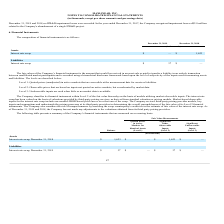According to Maxlinear's financial document, How is the fair value of the company's financial instrument defined? The fair values of the Company’s financial instrument is the amount that would be received in an asset sale or paid to transfer a liability in an orderly transaction between unaffiliated market participants and is recorded using a hierarchical disclosure framework based upon the level of subjectivity of the inputs used in measuring assets and liabilities.. The document states: "The fair values of the Company’s financial instrument is the amount that would be received in an asset sale or paid to transfer a liability in an orde..." Also, What was the interest rate swap in 2019 and 2018 respectively? The document shows two values: 0 and 1,623 (in thousands). From the document: "December 31, 2019 December 31, 2018 Interest rate swap $ — $ 1,623..." Additionally, In which year was interest rate swap less than 1,000 thousands? According to the financial document, 2019. The relevant text states: "December 31, 2019 December 31, 2018..." Also, can you calculate: What was the change in the interest rate swap from 2018 to 2019? Based on the calculation: 0 - 1,623, the result is -1623 (in thousands). This is based on the information: "December 31, 2019 December 31, 2018 Interest rate swap $ — $ 1,623..." The key data points involved are: 0, 1,623. Also, can you calculate: What was the average interest rate swap liabilities for 2018 and 2019? To answer this question, I need to perform calculations using the financial data. The calculation is: (37 + 0) / 2, which equals 18.5 (in thousands). This is based on the information: "Interest rate swap $ 37 $ — December 31, 2019 December 31, 2018..." The key data points involved are: 0, 37. Also, What are the 3 levels of subjectivity? The document contains multiple relevant values: Level 1: Quoted prices (unadjusted) in active markets that are accessible at the measurement date for assets or liabilities., Level 2: Observable prices that are based on inputs not quoted on active markets, but corroborated by market data, Level 3: Unobservable inputs are used when little or no market data is available. From the document: "Level 2: Observable prices that are based on inputs not quoted on active markets, but corroborated by market data. Level 3: Unobservable inputs are us..." 